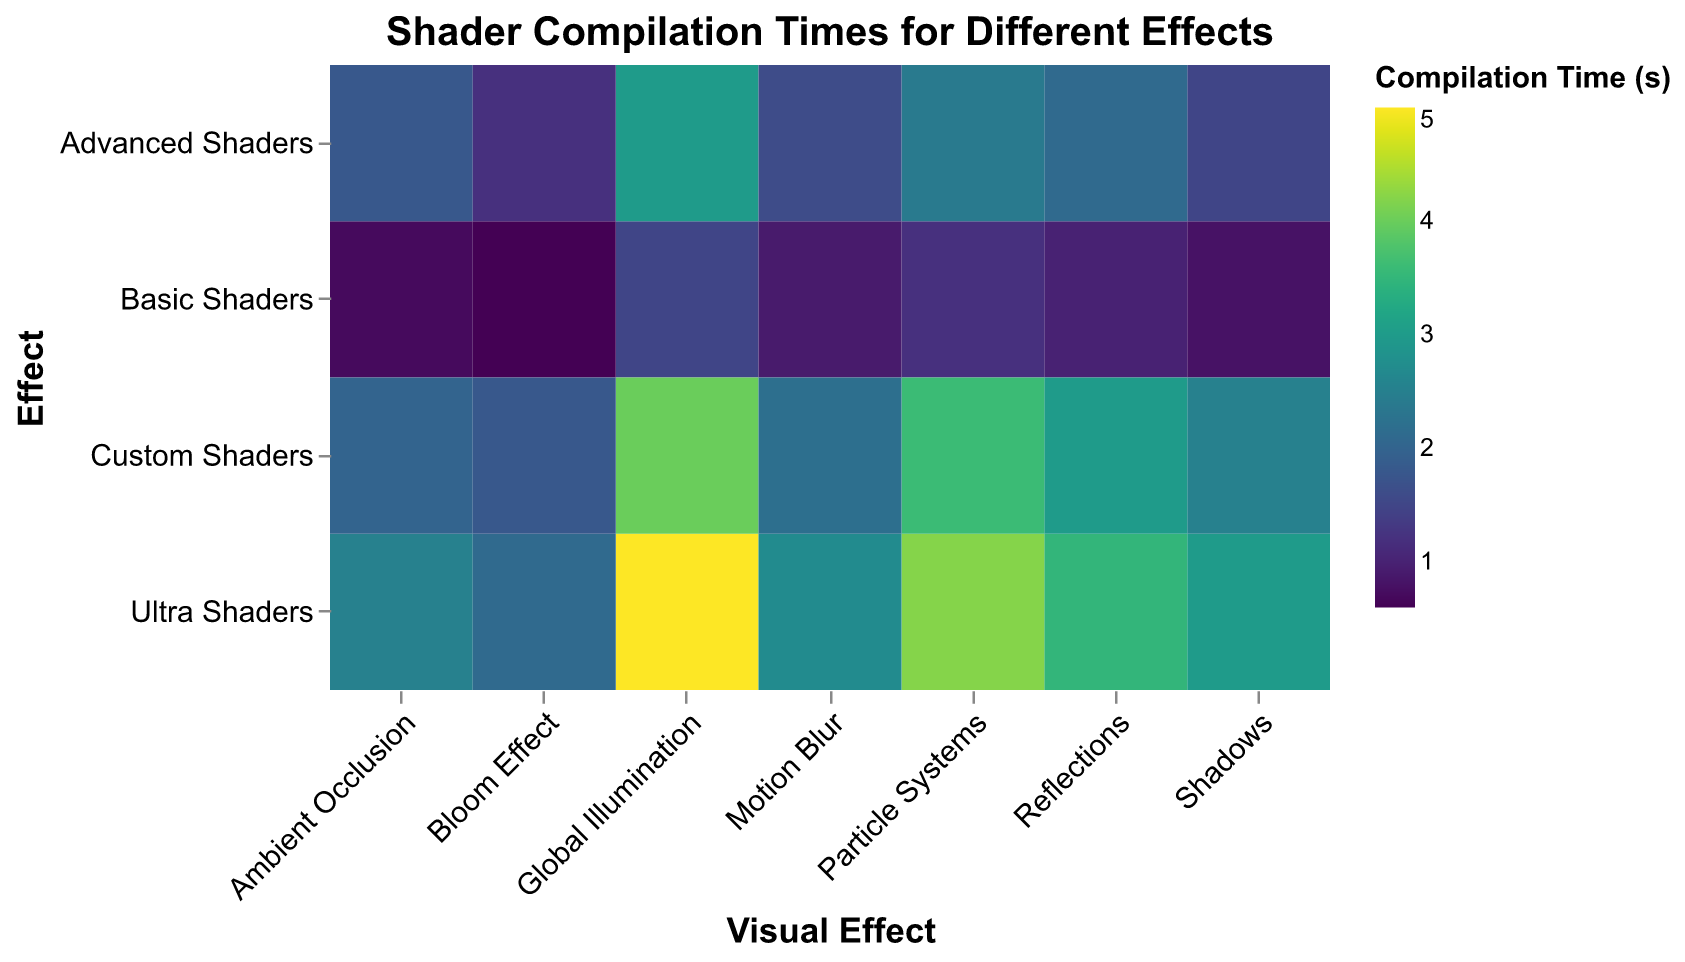What's the title of the figure? The title of the figure is displayed at the top and reads "Shader Compilation Times for Different Effects".
Answer: Shader Compilation Times for Different Effects On which axis are the shader types (e.g., Basic Shaders, Advanced Shaders, etc.) displayed? The shader types are displayed on the y-axis, which goes vertically from top to bottom.
Answer: y-axis What shader type has the longest compilation time for the Global Illumination effect? By examining the heatmap, the Ultra Shaders show the darkest color for the Global Illumination effect, indicating the longest time.
Answer: Ultra Shaders Which visual effect has the shortest compilation time for Basic Shaders? The lightest color for Basic Shaders corresponds to the Bloom Effect, indicating it has the shortest compilation time for that shader type.
Answer: Bloom Effect How does the compilation time for Reflections compare between Basic Shaders and Ultra Shaders? The color difference between Basic Shaders and Ultra Shaders for Reflections shows that Ultra Shaders take longer. For Basic Shaders, it's lighter (1.0 seconds) compared to Ultra Shaders (3.5 seconds).
Answer: Ultra Shaders take longer What is the average compilation time for Advanced Shaders across all visual effects? First, sum the compilation times for Advanced Shaders across all effects: 1.5 + 2.1 + 2.4 + 1.8 + 3.0 + 1.2 + 1.6 = 13.6. Then, divide by the number of effects: 13.6 / 7 ≈ 1.94 seconds.
Answer: 1.94 seconds Which visual effect shows the most significant increase in compilation time when moving from Basic Shaders to Ultra Shaders? Calculate the differences for each effect: Shadows (3.0 - 0.8 = 2.2), Reflections (3.5 - 1.0 = 2.5), Particle Systems (4.2 - 1.2 = 3.0), Ambient Occlusion (2.5 - 0.7 = 1.8), Global Illumination (5.0 - 1.5 = 3.5), Bloom Effect (2.1 - 0.6 = 1.5), Motion Blur (2.7 - 0.9 = 1.8). The largest increase is in Global Illumination.
Answer: Global Illumination For which shader type is the compilation time for Motion Blur closest to the compilation time for Particle Systems? Compare the times for Motion Blur and Particle Systems across shader types: Basic (0.9 vs. 1.2), Advanced (1.6 vs. 2.4), Ultra (2.7 vs. 4.2), Custom (2.2 vs. 3.6). The smallest difference is in Basic Shaders (0.9 and 1.2).
Answer: Basic Shaders What is the total compilation time for Custom Shaders across all visual effects? Sum the compilation times for Custom Shaders: 2.5 + 3.0 + 3.6 + 2.0 + 4.0 + 1.8 + 2.2 = 19.1 seconds.
Answer: 19.1 seconds Which shader type has the most uniform compilation times across different visual effects? Examine the range of compilation times for each shader type: Basic (0.6 to 1.5, range = 0.9), Advanced (1.2 to 3.0, range = 1.8), Ultra (2.1 to 5.0, range = 2.9), Custom (1.8 to 4.0, range = 2.2). Basic Shaders have the smallest range.
Answer: Basic Shaders 